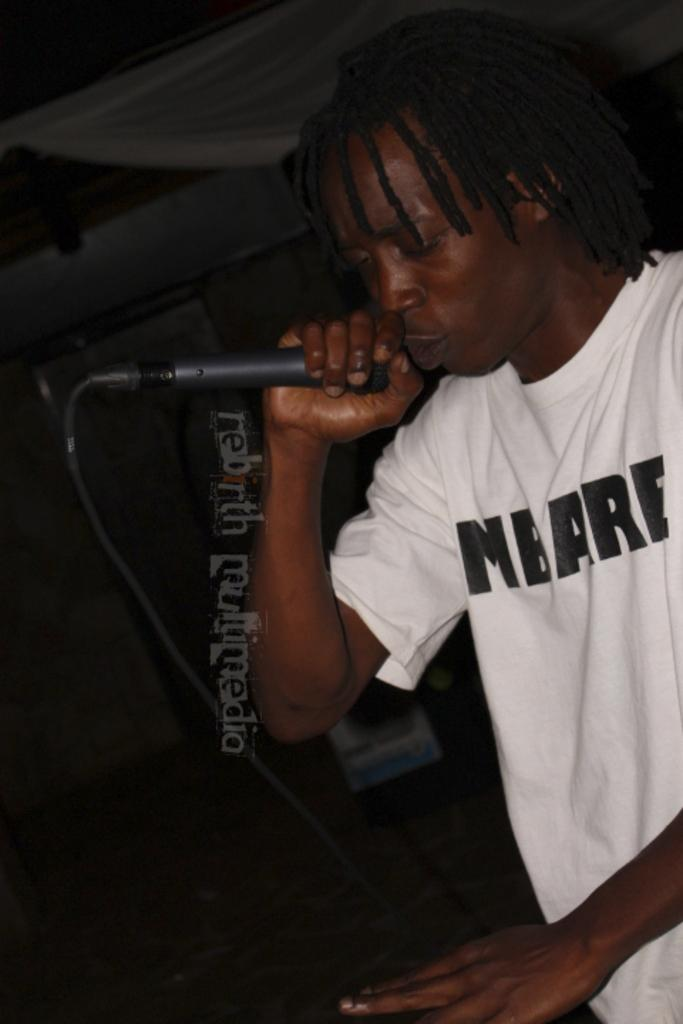What is the main subject of the image? There is a person in the image. What is the person holding in the image? The person is holding a mic. Can you describe any other objects in the image? There are objects in the image, but their specific details are not mentioned in the provided facts. What is visible at the top of the image? The roof is visible at the top of the image. How many books can be seen on the person's wrist in the image? There are no books or any reference to a wrist in the image. 